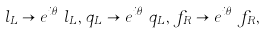<formula> <loc_0><loc_0><loc_500><loc_500>l _ { L } \to e ^ { i \theta _ { L } ^ { l } } l _ { L } , \, q _ { L } \to e ^ { i \theta _ { L } ^ { q } } q _ { L } , \, f _ { R } \to e ^ { i \theta _ { R } } f _ { R } ,</formula> 